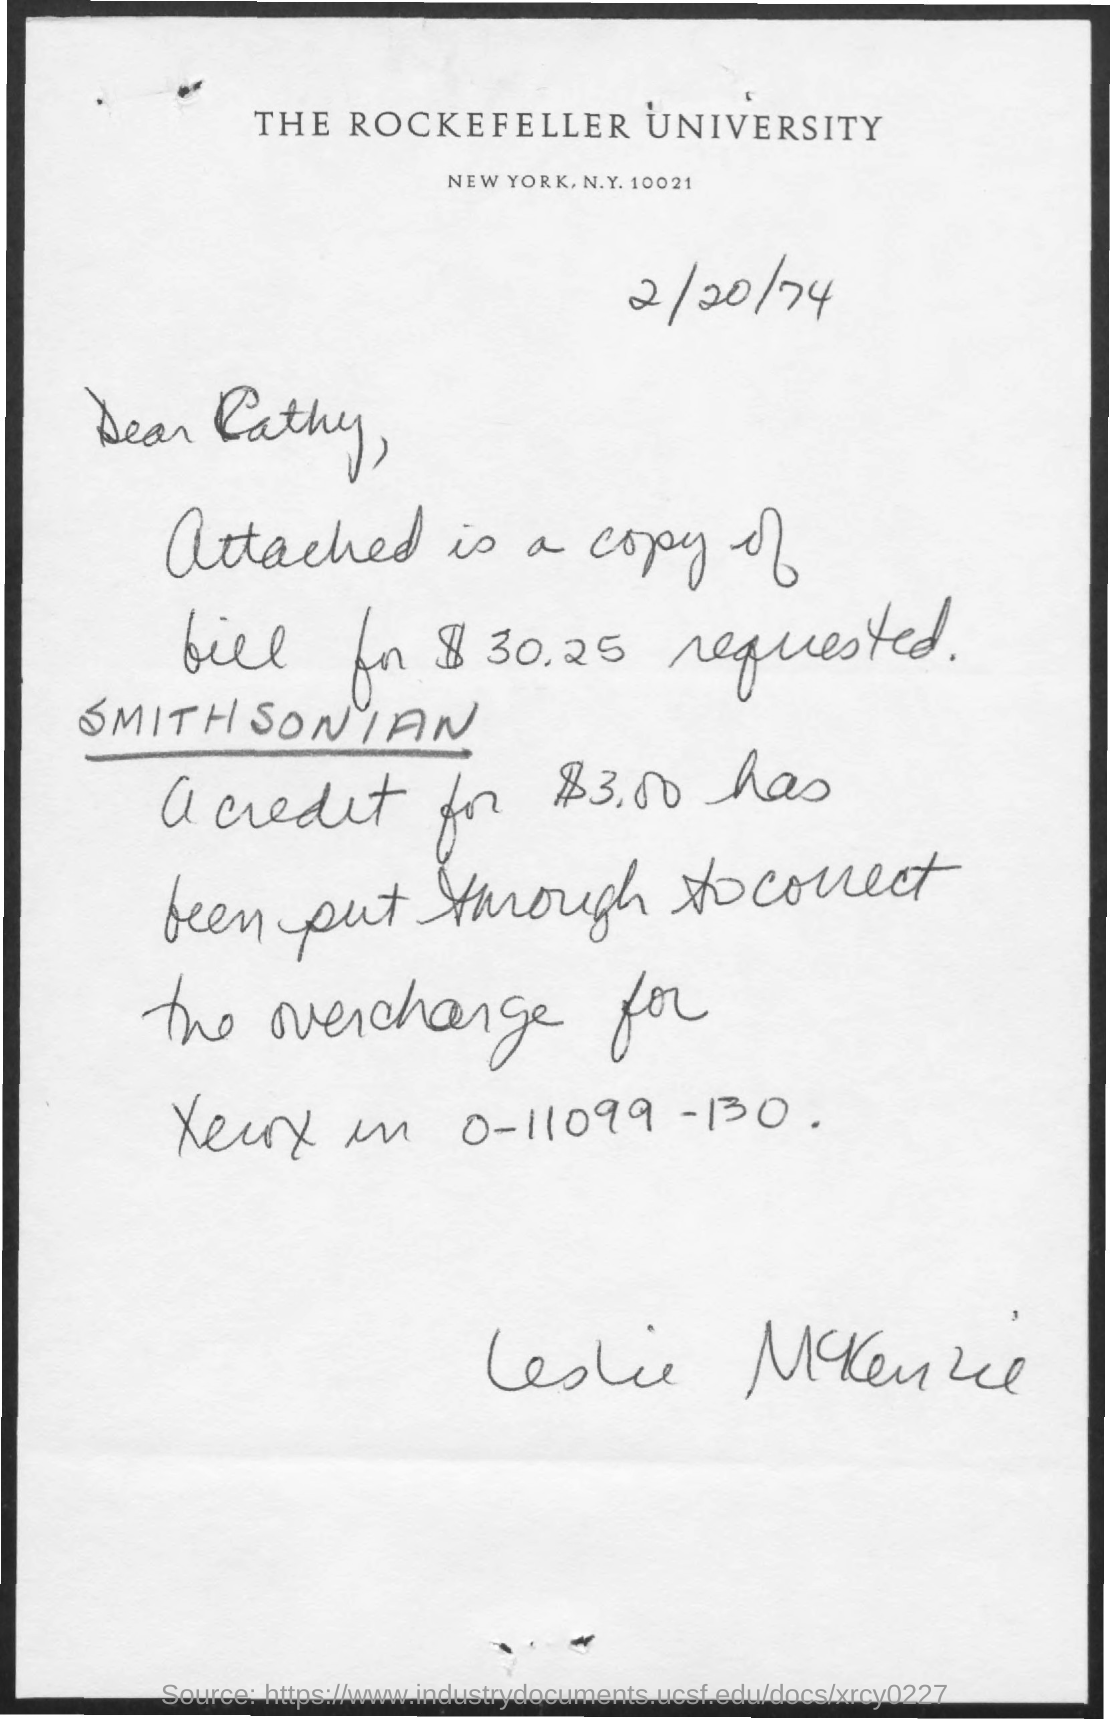Which university is mentioned?
Provide a succinct answer. THE ROCKEFELLER UNIVERSITY. When is the document dated?
Offer a terse response. 2/20/74. To whom is the letter addressed?
Ensure brevity in your answer.  Cathy. 